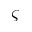<formula> <loc_0><loc_0><loc_500><loc_500>\varsigma</formula> 